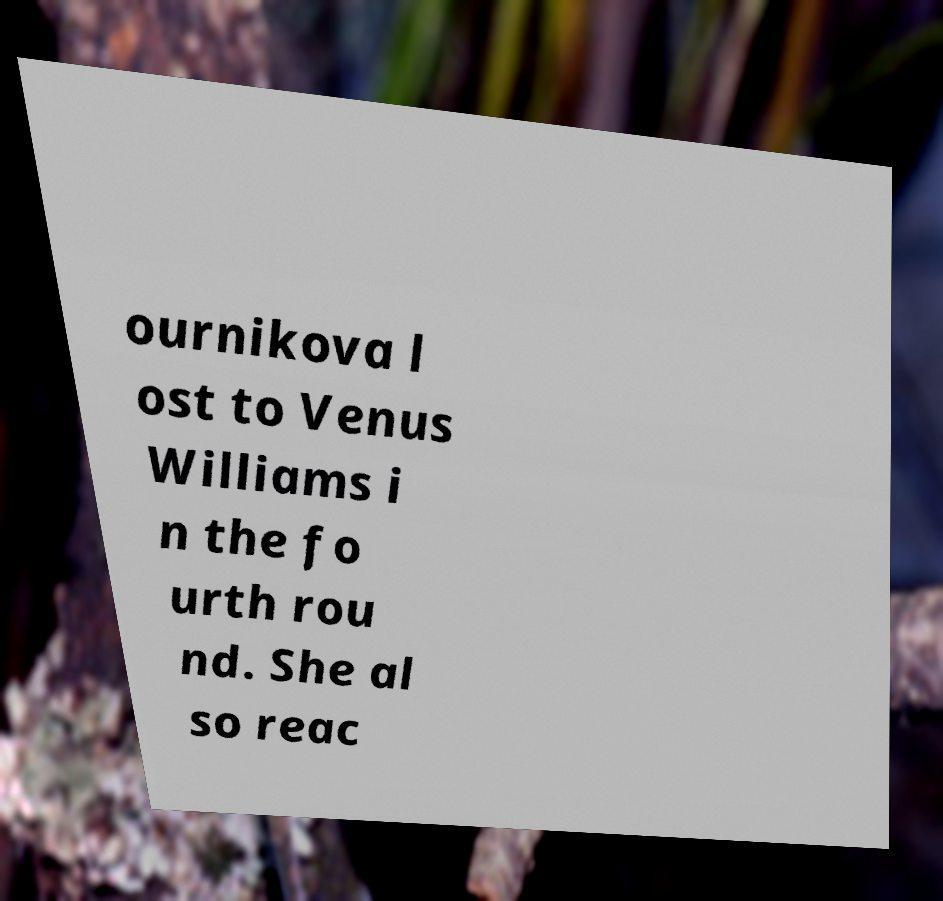Could you assist in decoding the text presented in this image and type it out clearly? ournikova l ost to Venus Williams i n the fo urth rou nd. She al so reac 